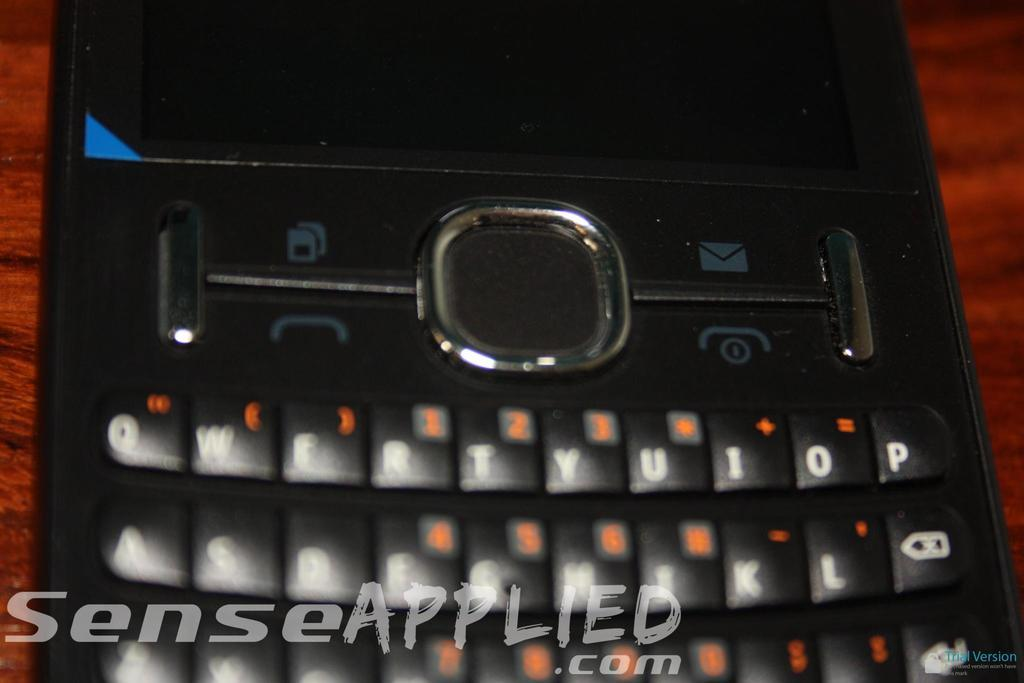<image>
Offer a succinct explanation of the picture presented. An electronic device is pictured with SenseApplied.com at the bottom of the photo. 